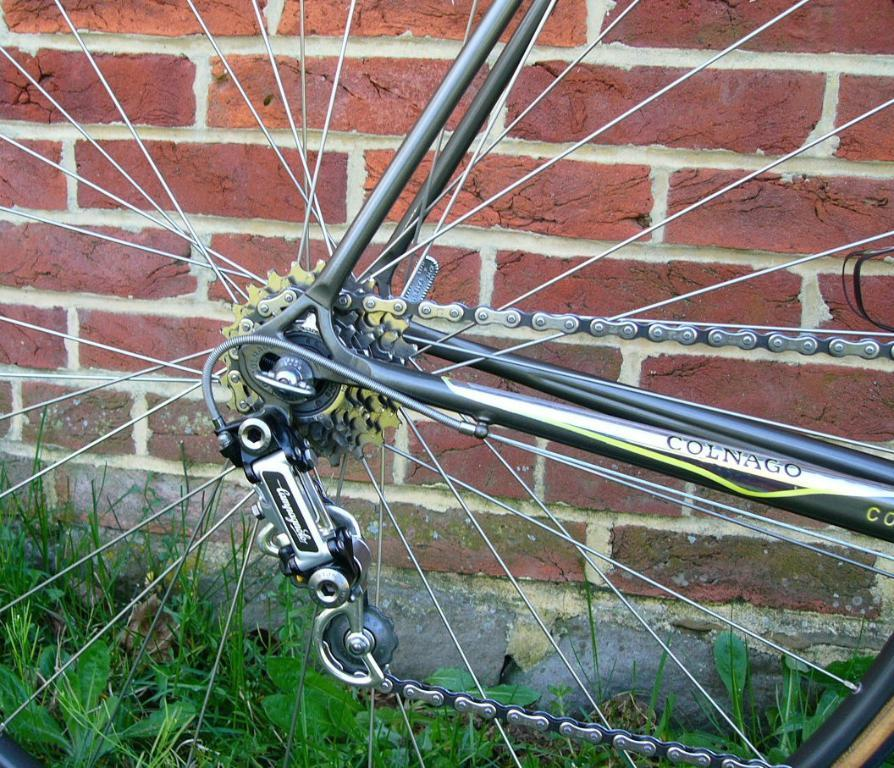What is the main object in the image? There is a bicycle wheel in the image. What else can be seen on the ground in the image? There are plants on the ground in the image. What type of structure is visible in the image? There is a brick wall in the image. What type of apple is being used by the government to fix the bicycle wheel in the image? There is no apple or government involvement in the image, and the bicycle wheel does not require fixing. 